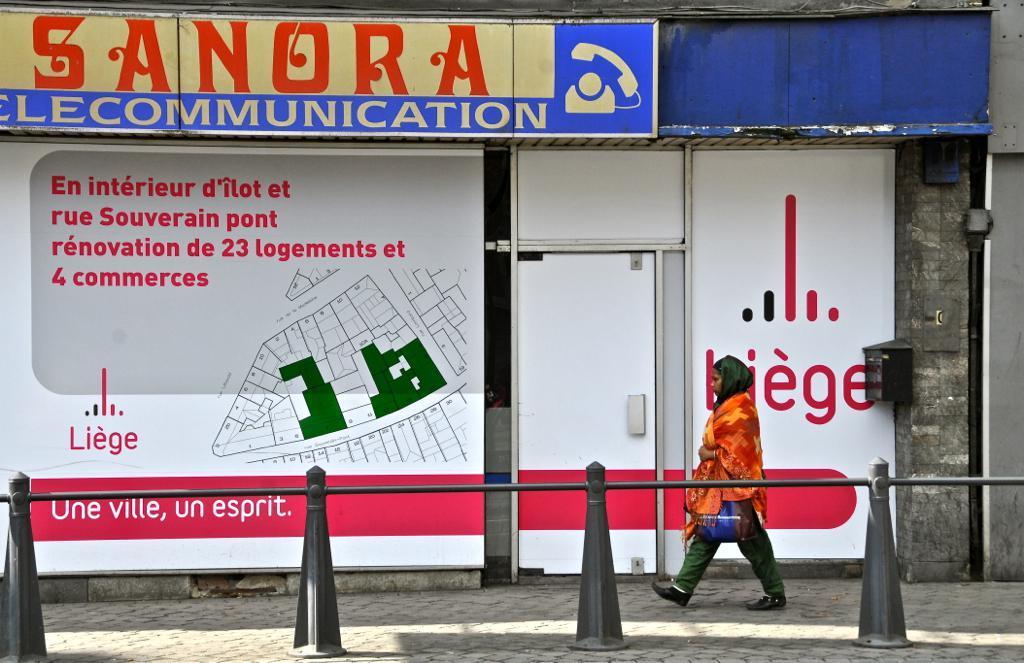How would you summarize this image in a sentence or two? In this image I can see a woman is walking on the ground and holding a bag. Here I can see some objects on the ground. In the background I can see boards on the wall. I can also see something written on boards. 